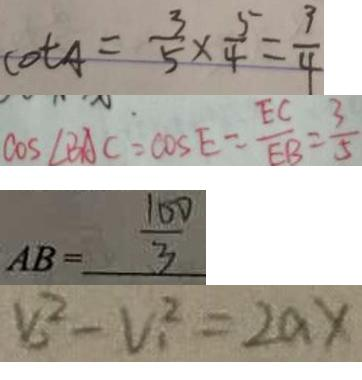Convert formula to latex. <formula><loc_0><loc_0><loc_500><loc_500>\cot A = \frac { 3 } { 5 } \times \frac { 5 } { 4 } = \frac { 3 } { 4 } 
 \cos \angle B A C = \cos E = \frac { E C } { E B } = \frac { 3 } { 5 } 
 A B = \frac { 1 0 0 } { 3 } 
 V _ { 2 } ^ { 2 } - V _ { 1 } ^ { 2 } = 2 a x</formula> 